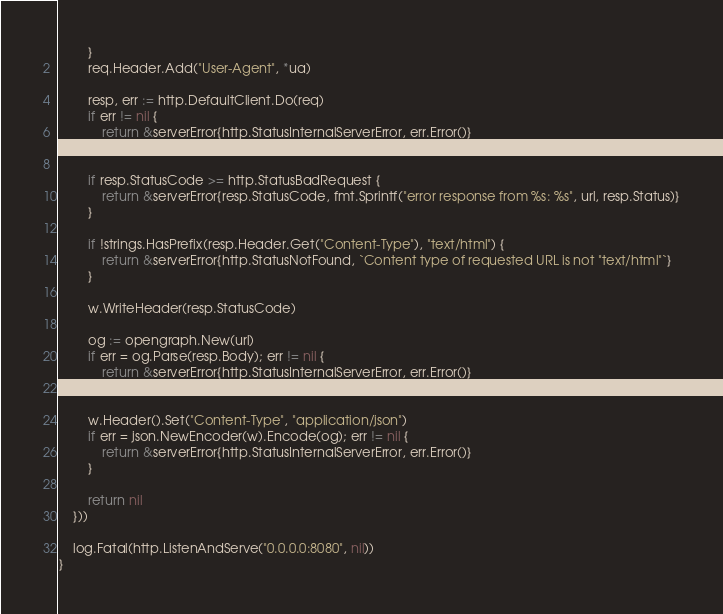Convert code to text. <code><loc_0><loc_0><loc_500><loc_500><_Go_>		}
		req.Header.Add("User-Agent", *ua)

		resp, err := http.DefaultClient.Do(req)
		if err != nil {
			return &serverError{http.StatusInternalServerError, err.Error()}
		}

		if resp.StatusCode >= http.StatusBadRequest {
			return &serverError{resp.StatusCode, fmt.Sprintf("error response from %s: %s", url, resp.Status)}
		}

		if !strings.HasPrefix(resp.Header.Get("Content-Type"), "text/html") {
			return &serverError{http.StatusNotFound, `Content type of requested URL is not "text/html"`}
		}

		w.WriteHeader(resp.StatusCode)

		og := opengraph.New(url)
		if err = og.Parse(resp.Body); err != nil {
			return &serverError{http.StatusInternalServerError, err.Error()}
		}

		w.Header().Set("Content-Type", "application/json")
		if err = json.NewEncoder(w).Encode(og); err != nil {
			return &serverError{http.StatusInternalServerError, err.Error()}
		}

		return nil
	}))

	log.Fatal(http.ListenAndServe("0.0.0.0:8080", nil))
}
</code> 